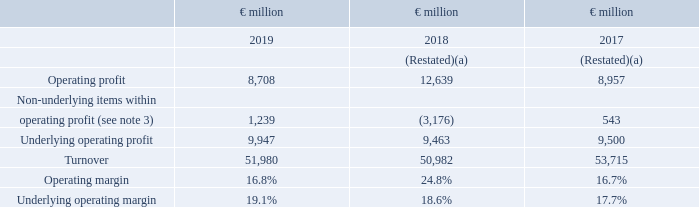Underlying operating profit and underlying operating margin
Underlying operating profit and underlying operating margin mean operating profit and operating margin before the impact of non-underlying items within operating profit. Underlying operating profit represents our measure of segment profit or loss as it is the primary measure used for making decisions about allocating resources and assessing performance of the segments.
The Group reconciliation of operating profit to underlying operating profit is as follows:
Further details of non-underlying items can be found in note 3 on page 96 of the consolidated financial statements.
Refer to Note 2 on page 94 for the reconciliation of operating profit to underlying operating profit by Division. For each Division operating margin is computed as operating profit divided by turnover and underlying operating margin is computed as underlying operating profit divided by turnover.
What does the underlying operating profit represent?  Underlying operating profit represents our measure of segment profit or loss as it is the primary measure used for making decisions about allocating resources and assessing performance of the segments. How is the operating margin computed? For each division operating margin is computed as operating profit divided by turnover and underlying operating margin is computed as underlying operating profit divided by turnover. What is the definition of the Underlying operating profit and underlying operating margin? Underlying operating profit and underlying operating margin mean operating profit and operating margin before the impact of non-underlying items within operating profit. What is the increase / (decrease) in the operating profit from 2018 to 2019?
Answer scale should be: million. 8,708 - 12,639
Answer: -3931. What is the increase / (decrease) in the operating margin from 2018 to 2019?
Answer scale should be: percent. 16.8 - 24.8
Answer: -8. What is the average turnover?
Answer scale should be: million. (51,980 + 50,982 + 53,715) / 3
Answer: 52225.67. 